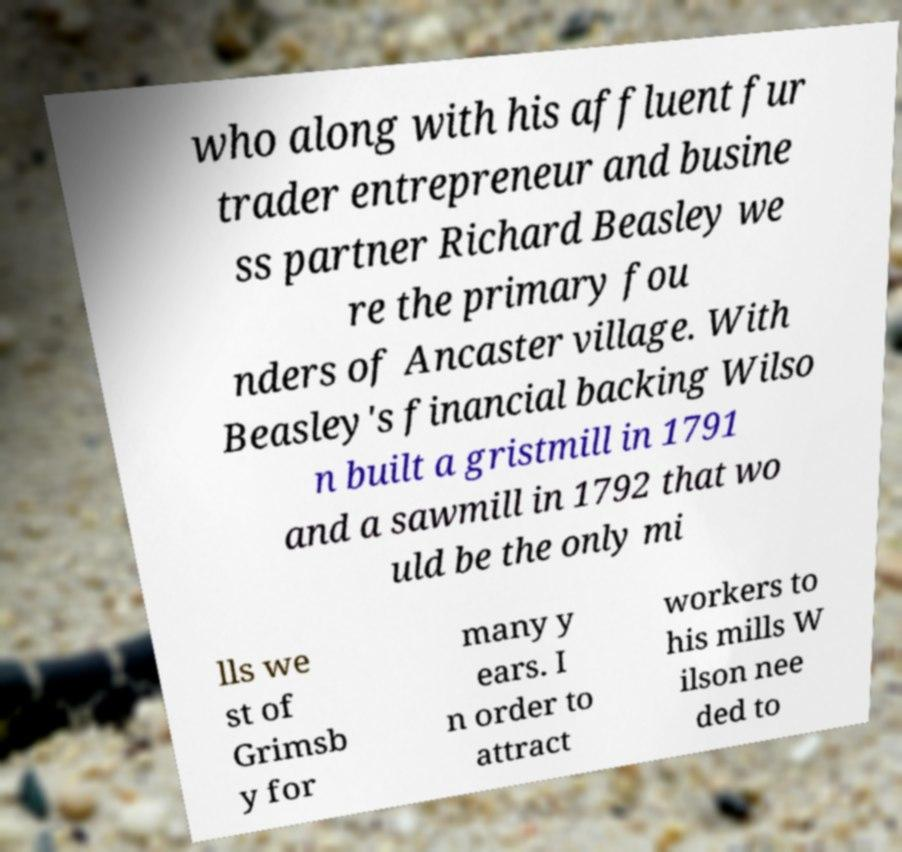Could you assist in decoding the text presented in this image and type it out clearly? who along with his affluent fur trader entrepreneur and busine ss partner Richard Beasley we re the primary fou nders of Ancaster village. With Beasley's financial backing Wilso n built a gristmill in 1791 and a sawmill in 1792 that wo uld be the only mi lls we st of Grimsb y for many y ears. I n order to attract workers to his mills W ilson nee ded to 